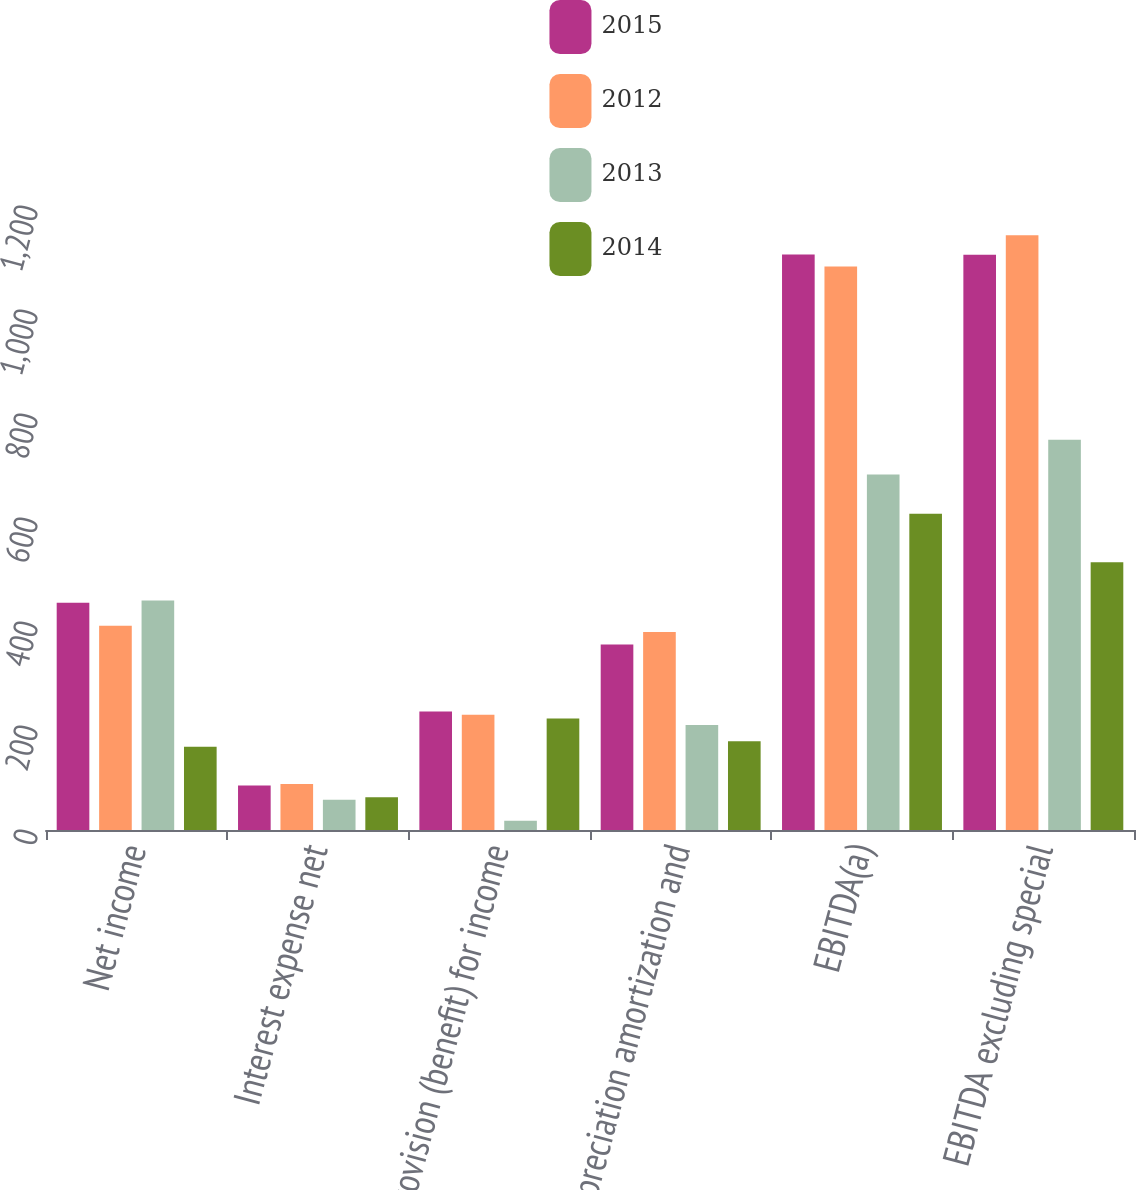Convert chart to OTSL. <chart><loc_0><loc_0><loc_500><loc_500><stacked_bar_chart><ecel><fcel>Net income<fcel>Interest expense net<fcel>Provision (benefit) for income<fcel>Depreciation amortization and<fcel>EBITDA(a)<fcel>EBITDA excluding special<nl><fcel>2015<fcel>436.8<fcel>85.5<fcel>227.7<fcel>356.5<fcel>1106.5<fcel>1106.2<nl><fcel>2012<fcel>392.6<fcel>88.4<fcel>221.7<fcel>381<fcel>1083.7<fcel>1143.6<nl><fcel>2013<fcel>441.3<fcel>58.3<fcel>17.7<fcel>201.8<fcel>683.7<fcel>750.7<nl><fcel>2014<fcel>160.2<fcel>62.9<fcel>214.5<fcel>170.8<fcel>608.4<fcel>514.9<nl></chart> 